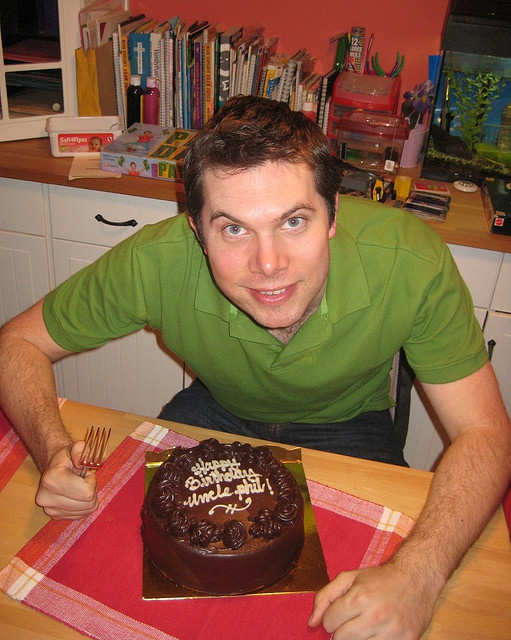Describe the objects in this image and their specific colors. I can see people in black, olive, and salmon tones, dining table in black, maroon, brown, and red tones, cake in black, maroon, tan, and gray tones, book in black, maroon, and gray tones, and book in black, gray, brown, and maroon tones in this image. 